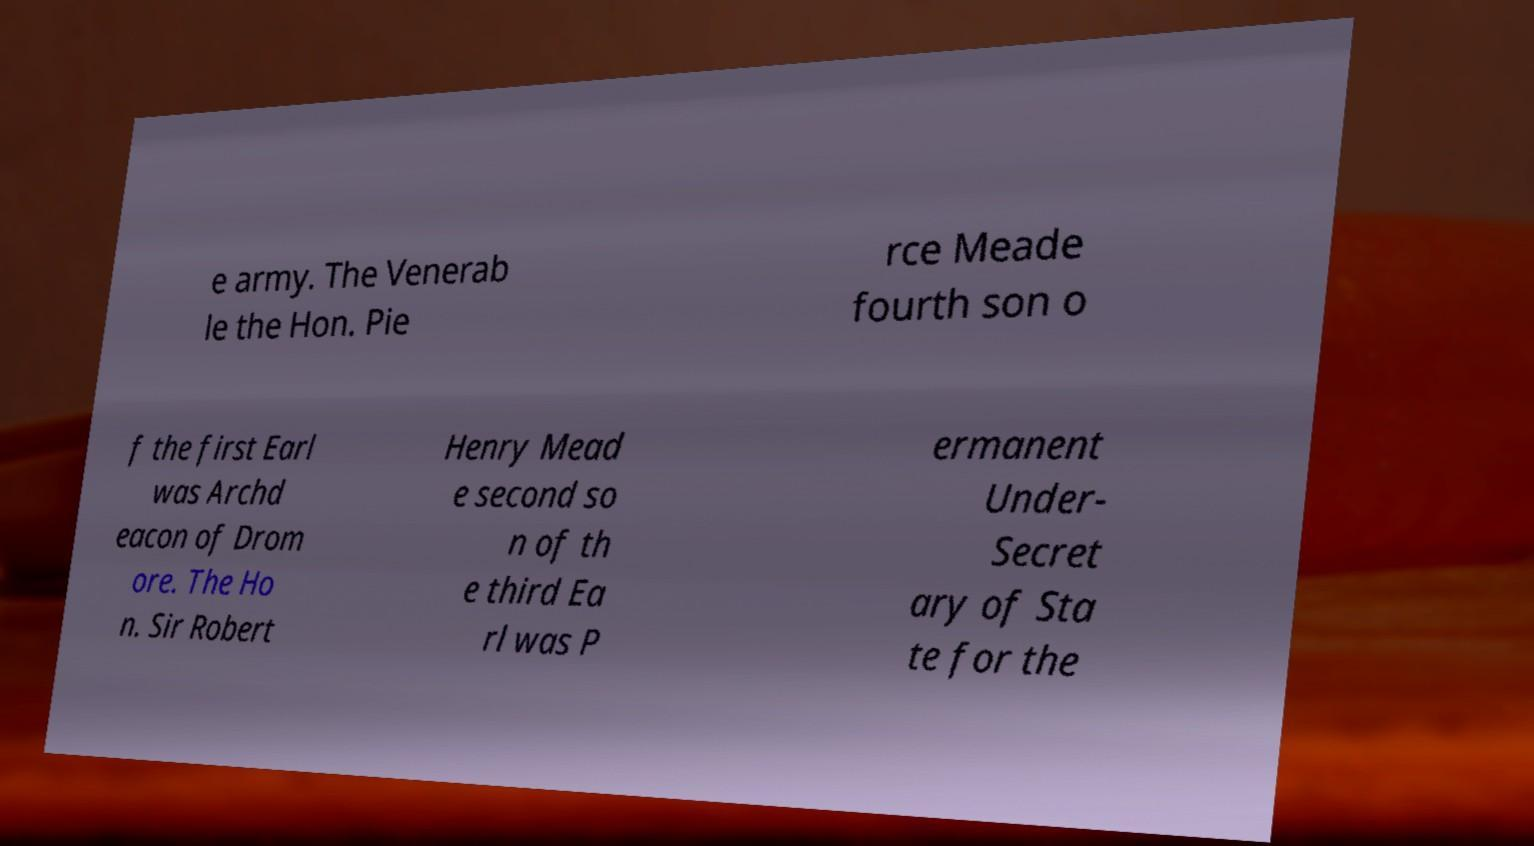Can you accurately transcribe the text from the provided image for me? e army. The Venerab le the Hon. Pie rce Meade fourth son o f the first Earl was Archd eacon of Drom ore. The Ho n. Sir Robert Henry Mead e second so n of th e third Ea rl was P ermanent Under- Secret ary of Sta te for the 